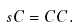<formula> <loc_0><loc_0><loc_500><loc_500>s C = C C .</formula> 